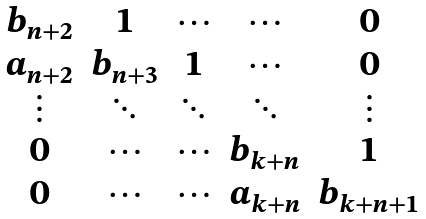<formula> <loc_0><loc_0><loc_500><loc_500>\begin{matrix} b _ { n + 2 } & 1 & \cdots & \cdots & 0 \\ a _ { n + 2 } & b _ { n + 3 } & 1 & \cdots & 0 \\ \vdots & \ddots & \ddots & \ddots & \vdots \\ 0 & \cdots & \cdots & b _ { k + n } & 1 \\ 0 & \cdots & \cdots & a _ { k + n } & b _ { k + n + 1 } \end{matrix}</formula> 